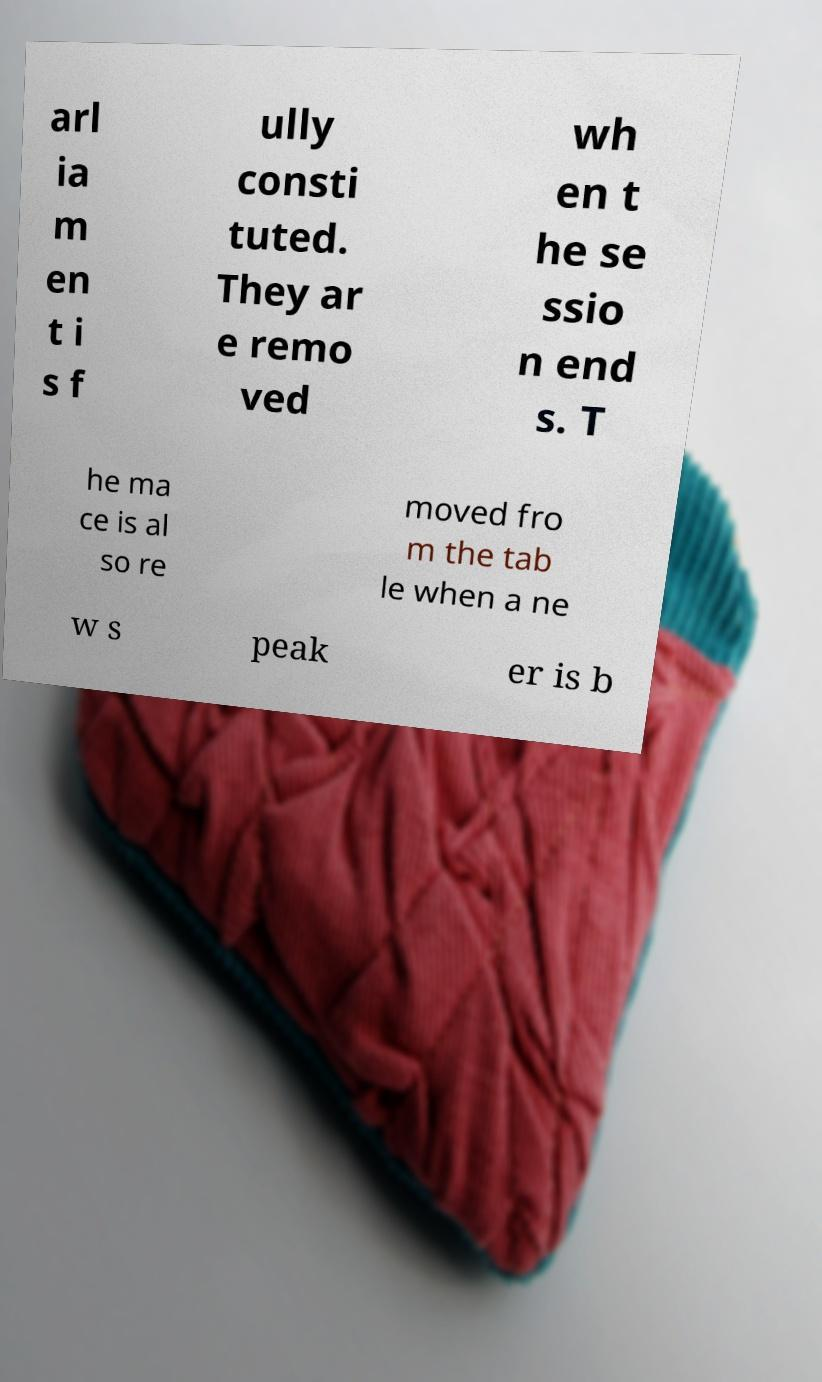Could you assist in decoding the text presented in this image and type it out clearly? arl ia m en t i s f ully consti tuted. They ar e remo ved wh en t he se ssio n end s. T he ma ce is al so re moved fro m the tab le when a ne w s peak er is b 